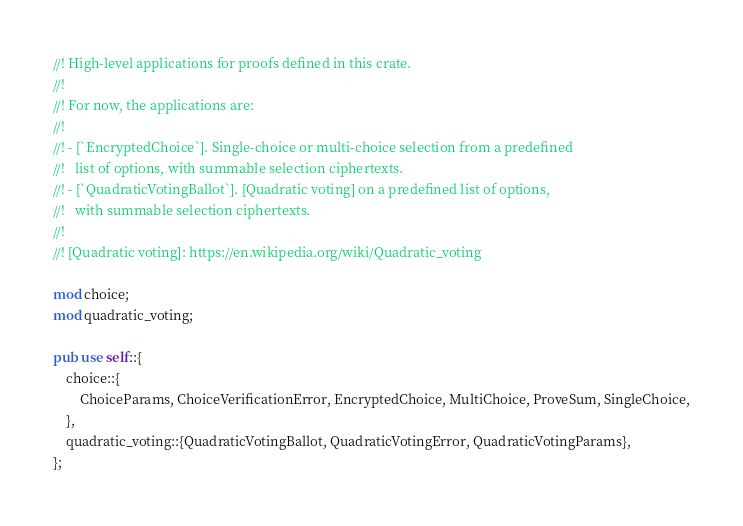<code> <loc_0><loc_0><loc_500><loc_500><_Rust_>//! High-level applications for proofs defined in this crate.
//!
//! For now, the applications are:
//!
//! - [`EncryptedChoice`]. Single-choice or multi-choice selection from a predefined
//!   list of options, with summable selection ciphertexts.
//! - [`QuadraticVotingBallot`]. [Quadratic voting] on a predefined list of options,
//!   with summable selection ciphertexts.
//!
//! [Quadratic voting]: https://en.wikipedia.org/wiki/Quadratic_voting

mod choice;
mod quadratic_voting;

pub use self::{
    choice::{
        ChoiceParams, ChoiceVerificationError, EncryptedChoice, MultiChoice, ProveSum, SingleChoice,
    },
    quadratic_voting::{QuadraticVotingBallot, QuadraticVotingError, QuadraticVotingParams},
};
</code> 